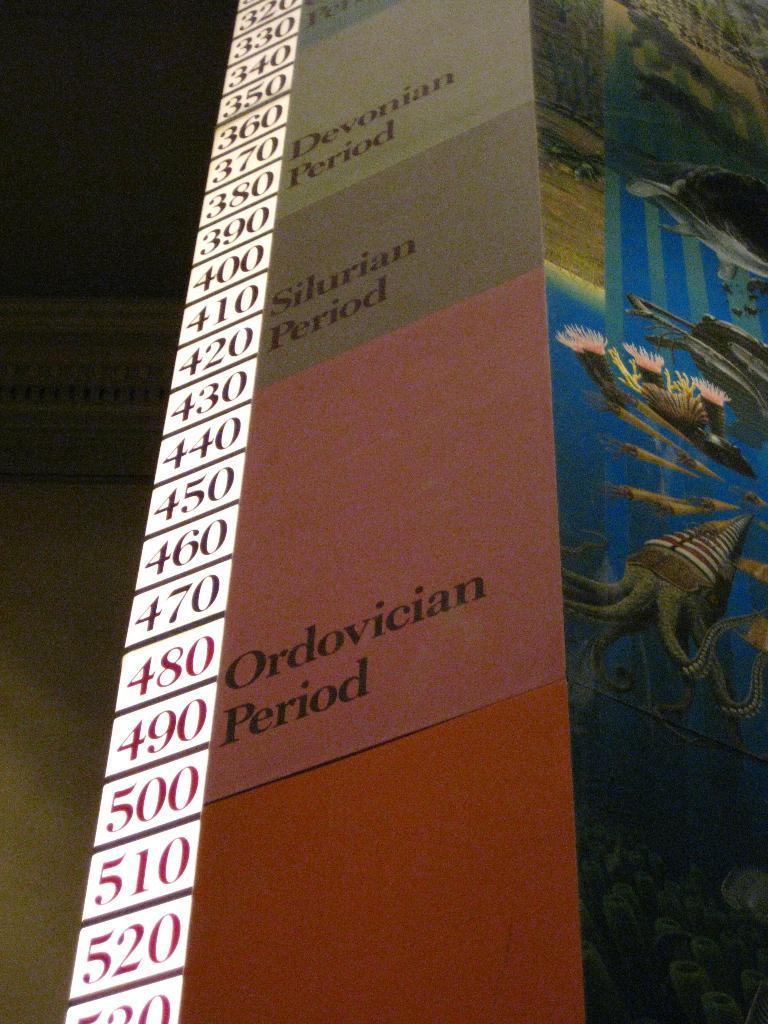Could you give a brief overview of what you see in this image? In this image I can see a board in orange, pink and gray color and something written on it. I can also see few numbers on it. 